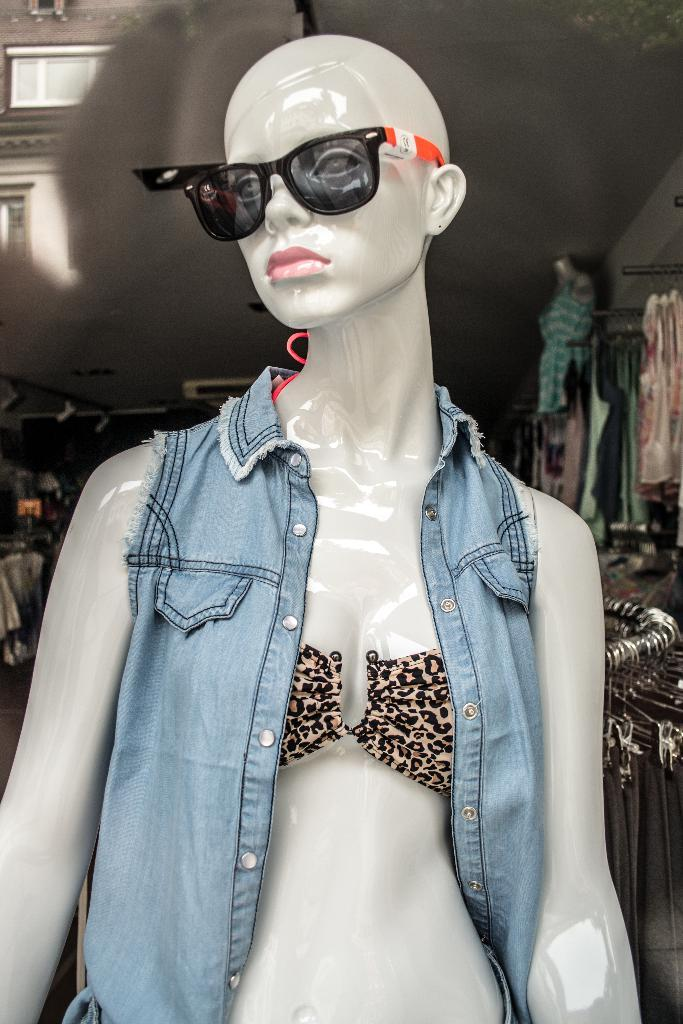What is in the foreground of the image? There is a mannequin in the foreground of the image. What is the mannequin wearing? The mannequin has spectacles. What can be seen in the background of the image? There are clothes hanging in the background of the image, and the ceiling is also visible. How many legs are visible on the mannequin in the image? The mannequin in the image does not have legs, as it is a display model for clothing. 